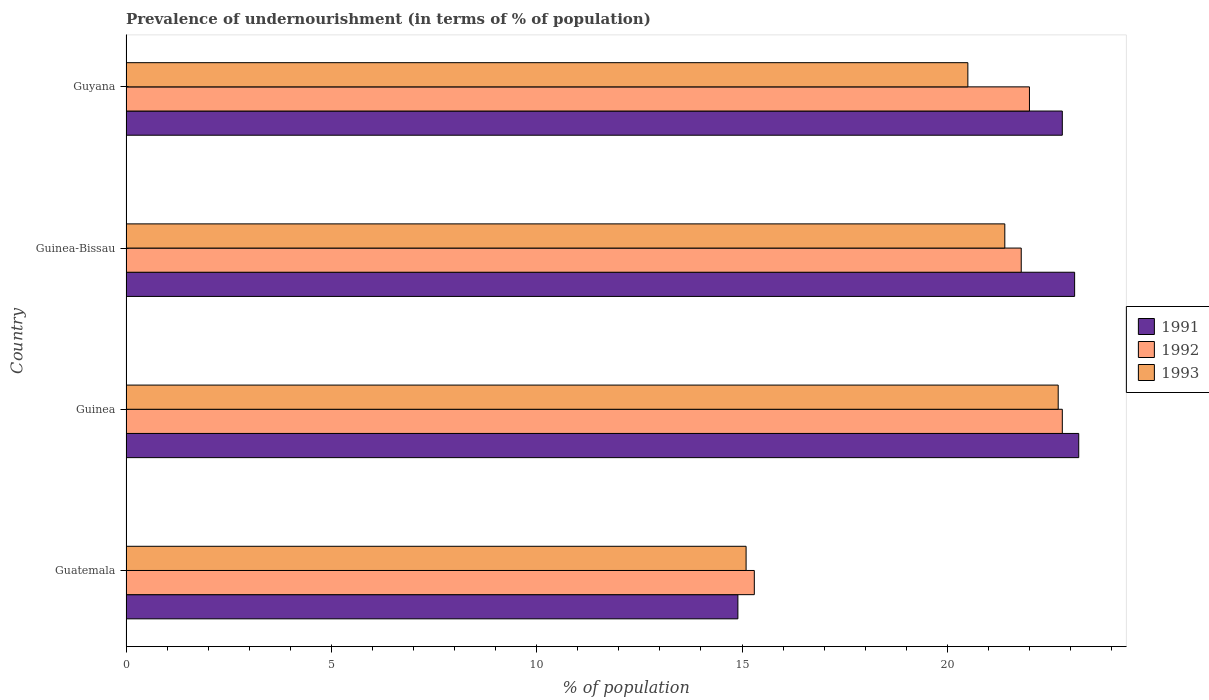How many groups of bars are there?
Offer a terse response. 4. Are the number of bars per tick equal to the number of legend labels?
Ensure brevity in your answer.  Yes. How many bars are there on the 2nd tick from the top?
Keep it short and to the point. 3. What is the label of the 2nd group of bars from the top?
Your answer should be compact. Guinea-Bissau. In how many cases, is the number of bars for a given country not equal to the number of legend labels?
Your answer should be very brief. 0. What is the percentage of undernourished population in 1991 in Guatemala?
Offer a terse response. 14.9. Across all countries, what is the maximum percentage of undernourished population in 1991?
Offer a terse response. 23.2. Across all countries, what is the minimum percentage of undernourished population in 1991?
Ensure brevity in your answer.  14.9. In which country was the percentage of undernourished population in 1991 maximum?
Offer a very short reply. Guinea. In which country was the percentage of undernourished population in 1993 minimum?
Provide a short and direct response. Guatemala. What is the total percentage of undernourished population in 1992 in the graph?
Provide a succinct answer. 81.9. What is the difference between the percentage of undernourished population in 1992 in Guatemala and the percentage of undernourished population in 1991 in Guinea?
Give a very brief answer. -7.9. What is the average percentage of undernourished population in 1993 per country?
Make the answer very short. 19.92. What is the difference between the percentage of undernourished population in 1993 and percentage of undernourished population in 1991 in Guinea-Bissau?
Ensure brevity in your answer.  -1.7. What is the ratio of the percentage of undernourished population in 1993 in Guinea-Bissau to that in Guyana?
Give a very brief answer. 1.04. Is the percentage of undernourished population in 1992 in Guinea-Bissau less than that in Guyana?
Keep it short and to the point. Yes. What is the difference between the highest and the second highest percentage of undernourished population in 1993?
Offer a very short reply. 1.3. What is the difference between the highest and the lowest percentage of undernourished population in 1992?
Give a very brief answer. 7.5. Is the sum of the percentage of undernourished population in 1992 in Guinea and Guyana greater than the maximum percentage of undernourished population in 1991 across all countries?
Make the answer very short. Yes. What does the 2nd bar from the top in Guyana represents?
Offer a very short reply. 1992. How many bars are there?
Ensure brevity in your answer.  12. Are all the bars in the graph horizontal?
Your response must be concise. Yes. What is the difference between two consecutive major ticks on the X-axis?
Your response must be concise. 5. Are the values on the major ticks of X-axis written in scientific E-notation?
Keep it short and to the point. No. Where does the legend appear in the graph?
Your response must be concise. Center right. How many legend labels are there?
Provide a short and direct response. 3. What is the title of the graph?
Provide a succinct answer. Prevalence of undernourishment (in terms of % of population). Does "1971" appear as one of the legend labels in the graph?
Provide a short and direct response. No. What is the label or title of the X-axis?
Your answer should be compact. % of population. What is the % of population in 1991 in Guatemala?
Your response must be concise. 14.9. What is the % of population of 1993 in Guatemala?
Your answer should be compact. 15.1. What is the % of population in 1991 in Guinea?
Your response must be concise. 23.2. What is the % of population in 1992 in Guinea?
Your answer should be compact. 22.8. What is the % of population of 1993 in Guinea?
Offer a terse response. 22.7. What is the % of population in 1991 in Guinea-Bissau?
Your response must be concise. 23.1. What is the % of population in 1992 in Guinea-Bissau?
Your answer should be very brief. 21.8. What is the % of population in 1993 in Guinea-Bissau?
Your answer should be very brief. 21.4. What is the % of population in 1991 in Guyana?
Offer a terse response. 22.8. What is the % of population of 1992 in Guyana?
Keep it short and to the point. 22. What is the % of population of 1993 in Guyana?
Provide a succinct answer. 20.5. Across all countries, what is the maximum % of population of 1991?
Give a very brief answer. 23.2. Across all countries, what is the maximum % of population of 1992?
Your response must be concise. 22.8. Across all countries, what is the maximum % of population in 1993?
Your answer should be compact. 22.7. Across all countries, what is the minimum % of population of 1991?
Provide a short and direct response. 14.9. Across all countries, what is the minimum % of population in 1992?
Your response must be concise. 15.3. Across all countries, what is the minimum % of population of 1993?
Make the answer very short. 15.1. What is the total % of population in 1992 in the graph?
Keep it short and to the point. 81.9. What is the total % of population of 1993 in the graph?
Provide a succinct answer. 79.7. What is the difference between the % of population in 1991 in Guatemala and that in Guinea?
Give a very brief answer. -8.3. What is the difference between the % of population of 1991 in Guatemala and that in Guinea-Bissau?
Offer a very short reply. -8.2. What is the difference between the % of population in 1992 in Guatemala and that in Guinea-Bissau?
Ensure brevity in your answer.  -6.5. What is the difference between the % of population in 1991 in Guatemala and that in Guyana?
Provide a short and direct response. -7.9. What is the difference between the % of population in 1993 in Guatemala and that in Guyana?
Give a very brief answer. -5.4. What is the difference between the % of population of 1991 in Guinea and that in Guinea-Bissau?
Your answer should be very brief. 0.1. What is the difference between the % of population in 1992 in Guinea and that in Guyana?
Offer a very short reply. 0.8. What is the difference between the % of population of 1992 in Guinea-Bissau and that in Guyana?
Give a very brief answer. -0.2. What is the difference between the % of population in 1991 in Guatemala and the % of population in 1992 in Guinea?
Make the answer very short. -7.9. What is the difference between the % of population in 1992 in Guatemala and the % of population in 1993 in Guinea?
Your answer should be very brief. -7.4. What is the difference between the % of population of 1991 in Guatemala and the % of population of 1992 in Guinea-Bissau?
Make the answer very short. -6.9. What is the difference between the % of population in 1991 in Guatemala and the % of population in 1993 in Guinea-Bissau?
Provide a short and direct response. -6.5. What is the difference between the % of population in 1992 in Guatemala and the % of population in 1993 in Guinea-Bissau?
Your response must be concise. -6.1. What is the difference between the % of population of 1991 in Guatemala and the % of population of 1993 in Guyana?
Your answer should be very brief. -5.6. What is the difference between the % of population in 1992 in Guinea and the % of population in 1993 in Guinea-Bissau?
Give a very brief answer. 1.4. What is the difference between the % of population in 1991 in Guinea and the % of population in 1993 in Guyana?
Your response must be concise. 2.7. What is the average % of population in 1991 per country?
Ensure brevity in your answer.  21. What is the average % of population of 1992 per country?
Your response must be concise. 20.48. What is the average % of population in 1993 per country?
Provide a short and direct response. 19.93. What is the difference between the % of population of 1991 and % of population of 1992 in Guatemala?
Offer a terse response. -0.4. What is the difference between the % of population in 1992 and % of population in 1993 in Guatemala?
Ensure brevity in your answer.  0.2. What is the difference between the % of population of 1991 and % of population of 1992 in Guinea?
Provide a short and direct response. 0.4. What is the difference between the % of population of 1991 and % of population of 1993 in Guinea?
Provide a short and direct response. 0.5. What is the difference between the % of population of 1991 and % of population of 1992 in Guinea-Bissau?
Offer a very short reply. 1.3. What is the difference between the % of population in 1992 and % of population in 1993 in Guinea-Bissau?
Offer a very short reply. 0.4. What is the difference between the % of population in 1992 and % of population in 1993 in Guyana?
Offer a terse response. 1.5. What is the ratio of the % of population in 1991 in Guatemala to that in Guinea?
Your response must be concise. 0.64. What is the ratio of the % of population of 1992 in Guatemala to that in Guinea?
Give a very brief answer. 0.67. What is the ratio of the % of population of 1993 in Guatemala to that in Guinea?
Your answer should be very brief. 0.67. What is the ratio of the % of population of 1991 in Guatemala to that in Guinea-Bissau?
Your answer should be compact. 0.65. What is the ratio of the % of population of 1992 in Guatemala to that in Guinea-Bissau?
Offer a terse response. 0.7. What is the ratio of the % of population of 1993 in Guatemala to that in Guinea-Bissau?
Offer a very short reply. 0.71. What is the ratio of the % of population of 1991 in Guatemala to that in Guyana?
Make the answer very short. 0.65. What is the ratio of the % of population in 1992 in Guatemala to that in Guyana?
Provide a short and direct response. 0.7. What is the ratio of the % of population of 1993 in Guatemala to that in Guyana?
Your response must be concise. 0.74. What is the ratio of the % of population of 1992 in Guinea to that in Guinea-Bissau?
Provide a short and direct response. 1.05. What is the ratio of the % of population of 1993 in Guinea to that in Guinea-Bissau?
Give a very brief answer. 1.06. What is the ratio of the % of population in 1991 in Guinea to that in Guyana?
Give a very brief answer. 1.02. What is the ratio of the % of population of 1992 in Guinea to that in Guyana?
Make the answer very short. 1.04. What is the ratio of the % of population of 1993 in Guinea to that in Guyana?
Give a very brief answer. 1.11. What is the ratio of the % of population in 1991 in Guinea-Bissau to that in Guyana?
Your answer should be very brief. 1.01. What is the ratio of the % of population in 1992 in Guinea-Bissau to that in Guyana?
Give a very brief answer. 0.99. What is the ratio of the % of population of 1993 in Guinea-Bissau to that in Guyana?
Provide a short and direct response. 1.04. What is the difference between the highest and the second highest % of population of 1993?
Ensure brevity in your answer.  1.3. What is the difference between the highest and the lowest % of population of 1991?
Your answer should be compact. 8.3. What is the difference between the highest and the lowest % of population of 1993?
Your answer should be compact. 7.6. 